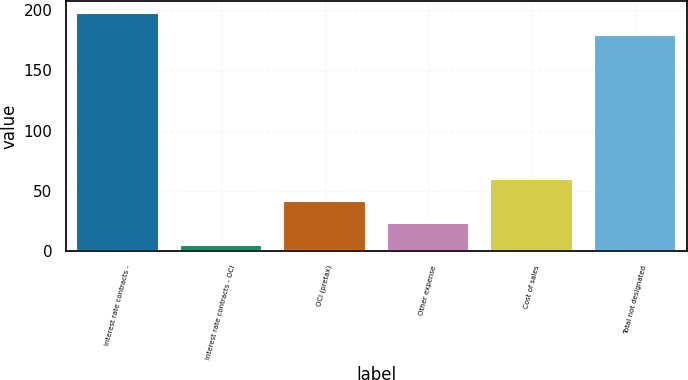Convert chart to OTSL. <chart><loc_0><loc_0><loc_500><loc_500><bar_chart><fcel>Interest rate contracts -<fcel>Interest rate contracts - OCI<fcel>OCI (pretax)<fcel>Other expense<fcel>Cost of sales<fcel>Total not designated<nl><fcel>197.3<fcel>5<fcel>41.6<fcel>23.3<fcel>59.9<fcel>179<nl></chart> 